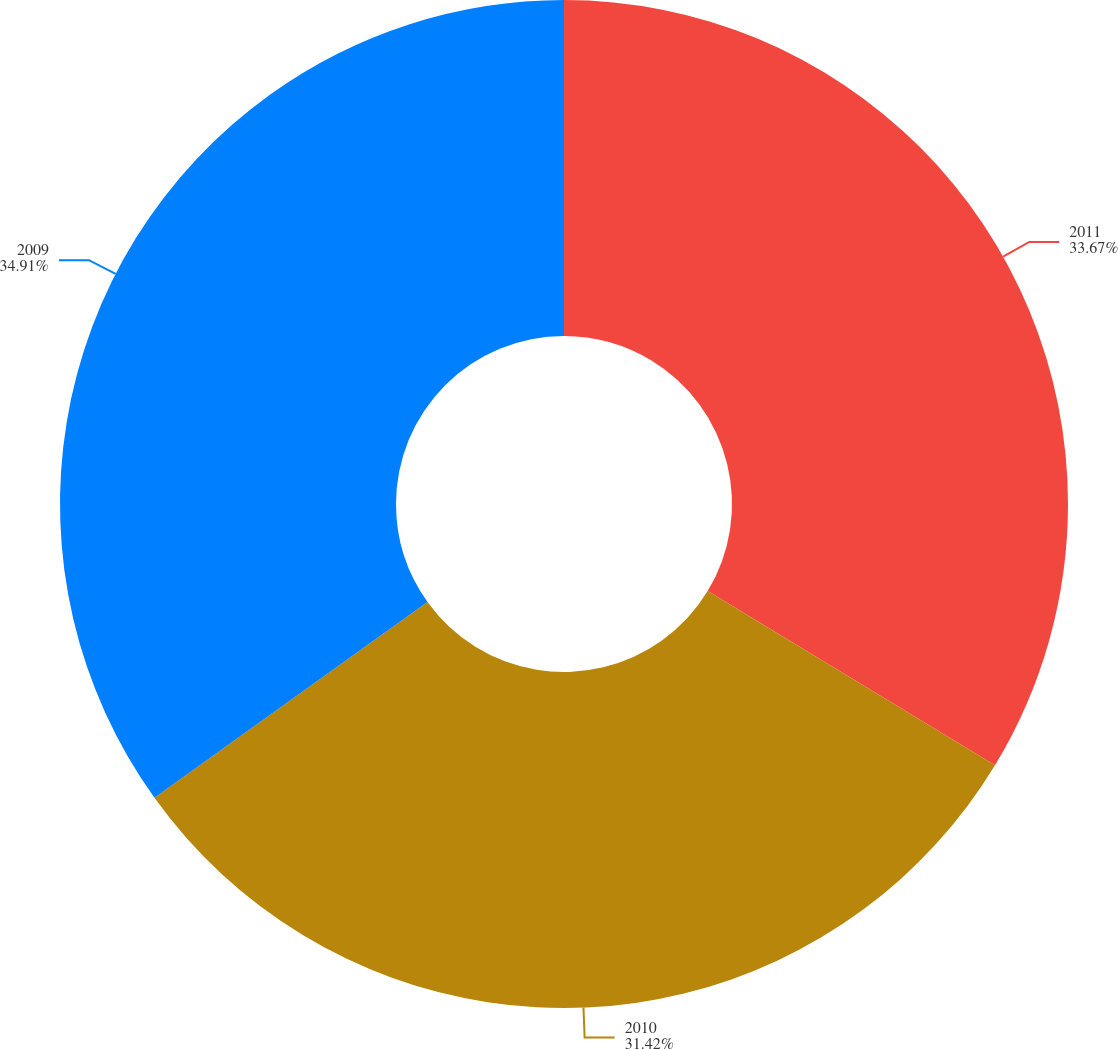Convert chart to OTSL. <chart><loc_0><loc_0><loc_500><loc_500><pie_chart><fcel>2011<fcel>2010<fcel>2009<nl><fcel>33.67%<fcel>31.42%<fcel>34.9%<nl></chart> 